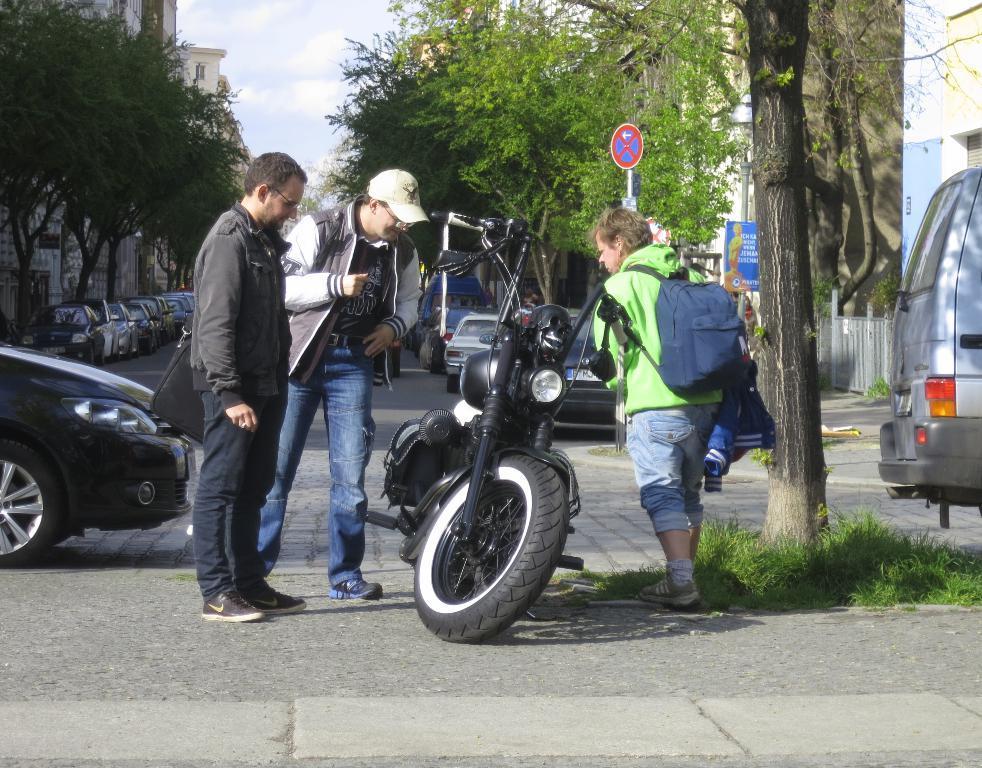How would you summarize this image in a sentence or two? In this image we can see there are persons standing on the road. And on the road there are grass, Motorcycle, Cars and board. And there are trees, Buildings and at the top there is a sky. 